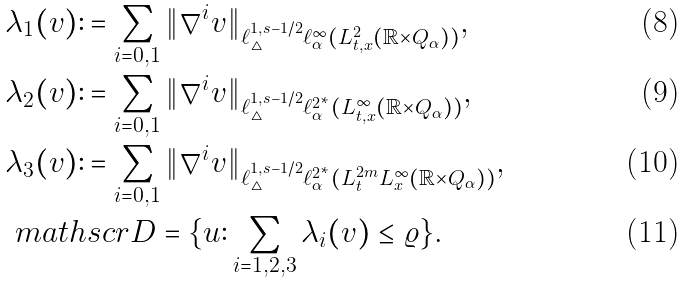<formula> <loc_0><loc_0><loc_500><loc_500>& \lambda _ { 1 } ( v ) \colon = \sum _ { i = 0 , 1 } \| \nabla ^ { i } v \| _ { \ell ^ { 1 , s - 1 / 2 } _ { \triangle } \ell ^ { \infty } _ { \alpha } ( L ^ { 2 } _ { t , x } ( \mathbb { R } \times Q _ { \alpha } ) ) } , \\ & \lambda _ { 2 } ( v ) \colon = \sum _ { i = 0 , 1 } \| \nabla ^ { i } v \| _ { \ell ^ { 1 , s - 1 / 2 } _ { \triangle } \ell ^ { 2 ^ { * } } _ { \alpha } ( L ^ { \infty } _ { t , x } ( \mathbb { R } \times Q _ { \alpha } ) ) } , \\ & \lambda _ { 3 } ( v ) \colon = \sum _ { i = 0 , 1 } \| \nabla ^ { i } v \| _ { \ell ^ { 1 , s - 1 / 2 } _ { \triangle } \ell ^ { 2 ^ { * } } _ { \alpha } ( L ^ { 2 m } _ { t } L ^ { \infty } _ { x } ( \mathbb { R } \times Q _ { \alpha } ) ) } , \\ & \ m a t h s c r { D } = \{ u \colon \sum _ { i = 1 , 2 , 3 } \lambda _ { i } ( v ) \leq \varrho \} .</formula> 